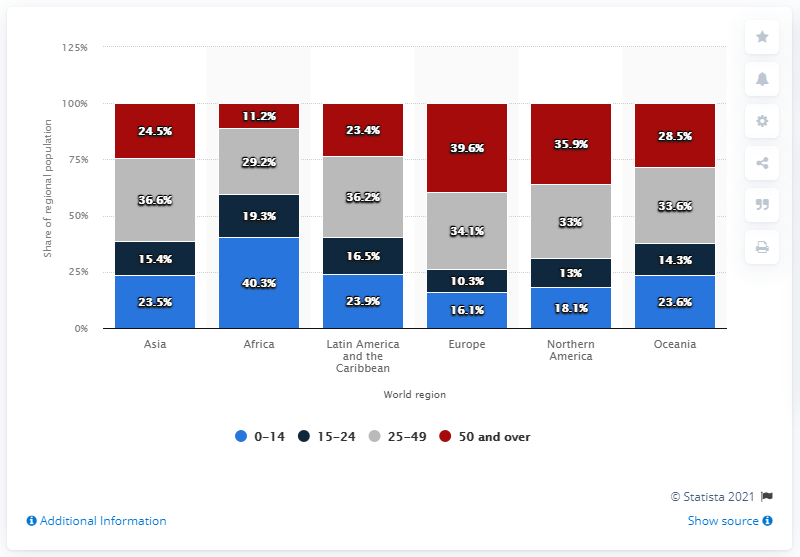Identify some key points in this picture. The percentage of people in Europe with an age group of over 50 is significantly lower than the percentage of people with an age group of 0-14. Specifically, the percentage of people with an age group of over 50 is 23.5%. The continent with the highest red bar is Europe. 